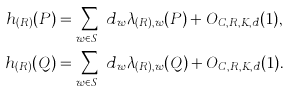Convert formula to latex. <formula><loc_0><loc_0><loc_500><loc_500>h _ { ( R ) } ( P ) & = \sum _ { w \in S _ { L } } d _ { w } \lambda _ { ( R ) , w } ( P ) + O _ { C , R , K , d } ( 1 ) , \\ h _ { ( R ) } ( Q ) & = \sum _ { w \in S _ { L } } d _ { w } \lambda _ { ( R ) , w } ( Q ) + O _ { C , R , K , d } ( 1 ) .</formula> 